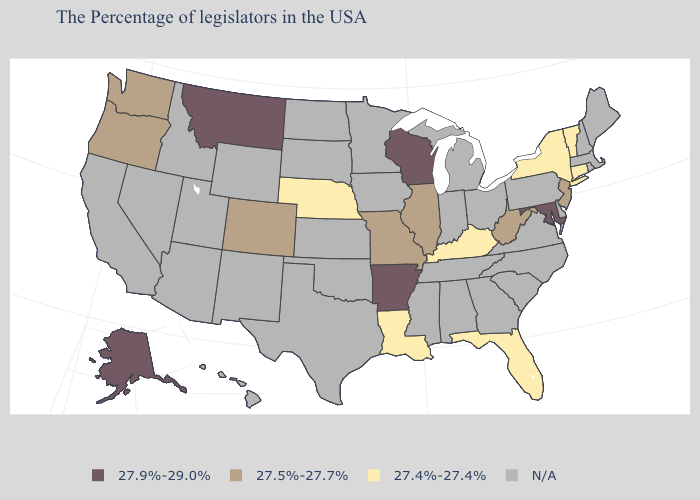Name the states that have a value in the range 27.4%-27.4%?
Short answer required. Vermont, Connecticut, New York, Florida, Kentucky, Louisiana, Nebraska. Name the states that have a value in the range N/A?
Short answer required. Maine, Massachusetts, Rhode Island, New Hampshire, Delaware, Pennsylvania, Virginia, North Carolina, South Carolina, Ohio, Georgia, Michigan, Indiana, Alabama, Tennessee, Mississippi, Minnesota, Iowa, Kansas, Oklahoma, Texas, South Dakota, North Dakota, Wyoming, New Mexico, Utah, Arizona, Idaho, Nevada, California, Hawaii. What is the highest value in the MidWest ?
Write a very short answer. 27.9%-29.0%. Name the states that have a value in the range 27.4%-27.4%?
Quick response, please. Vermont, Connecticut, New York, Florida, Kentucky, Louisiana, Nebraska. Is the legend a continuous bar?
Be succinct. No. Name the states that have a value in the range 27.4%-27.4%?
Write a very short answer. Vermont, Connecticut, New York, Florida, Kentucky, Louisiana, Nebraska. Name the states that have a value in the range 27.5%-27.7%?
Concise answer only. New Jersey, West Virginia, Illinois, Missouri, Colorado, Washington, Oregon. Name the states that have a value in the range 27.9%-29.0%?
Quick response, please. Maryland, Wisconsin, Arkansas, Montana, Alaska. What is the value of Utah?
Concise answer only. N/A. What is the value of Arkansas?
Keep it brief. 27.9%-29.0%. What is the value of Hawaii?
Give a very brief answer. N/A. Which states hav the highest value in the MidWest?
Keep it brief. Wisconsin. Does Alaska have the highest value in the USA?
Answer briefly. Yes. What is the value of Pennsylvania?
Be succinct. N/A. Among the states that border Pennsylvania , does New York have the lowest value?
Concise answer only. Yes. 